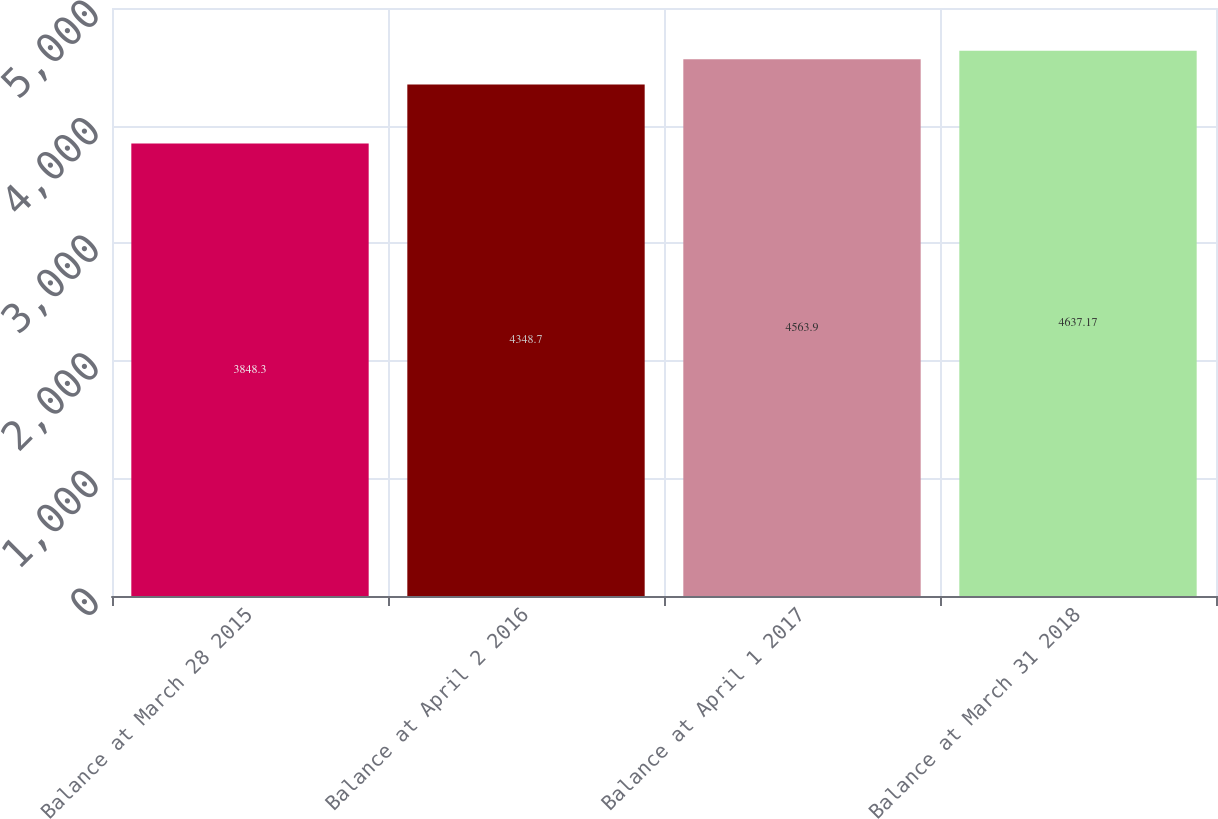Convert chart. <chart><loc_0><loc_0><loc_500><loc_500><bar_chart><fcel>Balance at March 28 2015<fcel>Balance at April 2 2016<fcel>Balance at April 1 2017<fcel>Balance at March 31 2018<nl><fcel>3848.3<fcel>4348.7<fcel>4563.9<fcel>4637.17<nl></chart> 